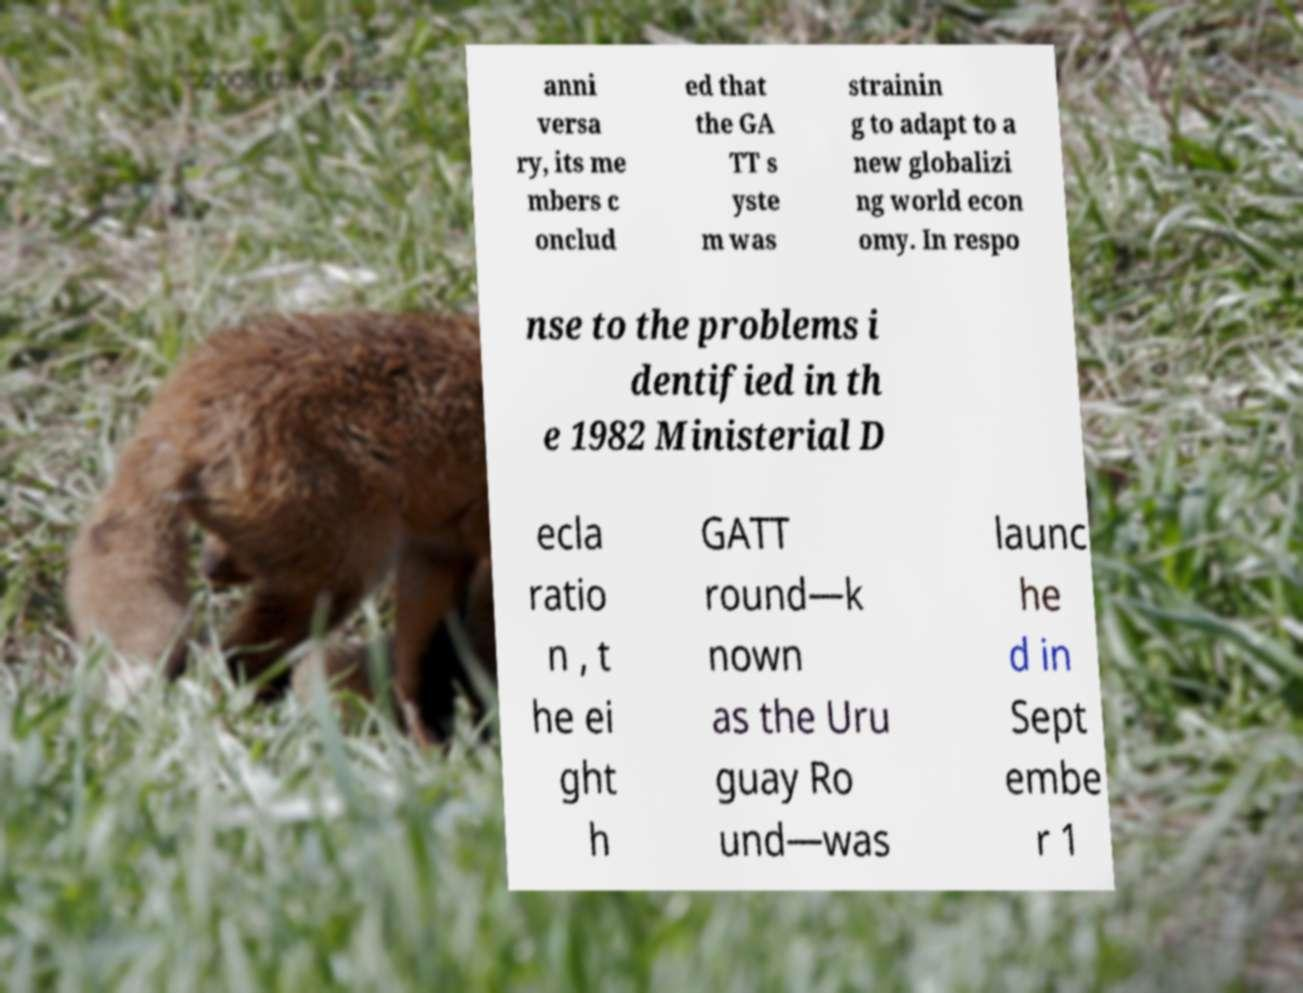Could you assist in decoding the text presented in this image and type it out clearly? anni versa ry, its me mbers c onclud ed that the GA TT s yste m was strainin g to adapt to a new globalizi ng world econ omy. In respo nse to the problems i dentified in th e 1982 Ministerial D ecla ratio n , t he ei ght h GATT round—k nown as the Uru guay Ro und—was launc he d in Sept embe r 1 